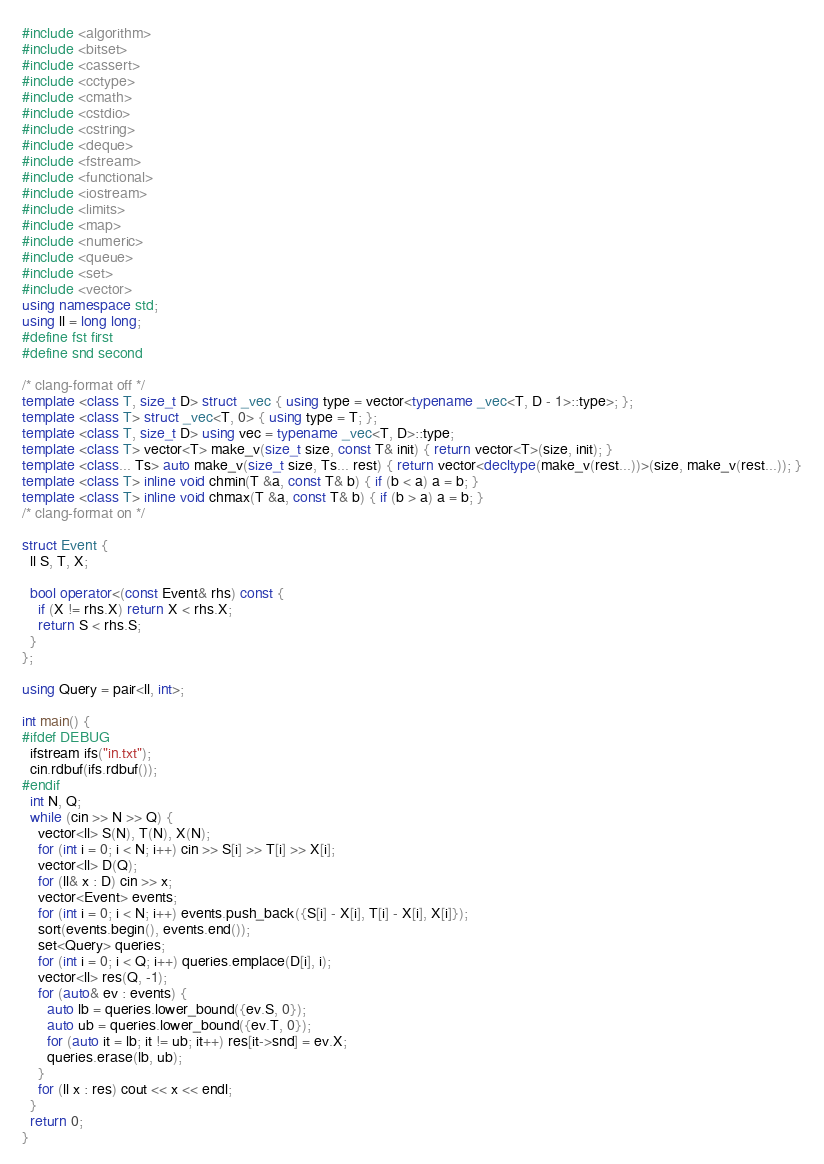<code> <loc_0><loc_0><loc_500><loc_500><_C++_>#include <algorithm>
#include <bitset>
#include <cassert>
#include <cctype>
#include <cmath>
#include <cstdio>
#include <cstring>
#include <deque>
#include <fstream>
#include <functional>
#include <iostream>
#include <limits>
#include <map>
#include <numeric>
#include <queue>
#include <set>
#include <vector>
using namespace std;
using ll = long long;
#define fst first
#define snd second

/* clang-format off */
template <class T, size_t D> struct _vec { using type = vector<typename _vec<T, D - 1>::type>; };
template <class T> struct _vec<T, 0> { using type = T; };
template <class T, size_t D> using vec = typename _vec<T, D>::type;
template <class T> vector<T> make_v(size_t size, const T& init) { return vector<T>(size, init); }
template <class... Ts> auto make_v(size_t size, Ts... rest) { return vector<decltype(make_v(rest...))>(size, make_v(rest...)); }
template <class T> inline void chmin(T &a, const T& b) { if (b < a) a = b; }
template <class T> inline void chmax(T &a, const T& b) { if (b > a) a = b; }
/* clang-format on */

struct Event {
  ll S, T, X;

  bool operator<(const Event& rhs) const {
    if (X != rhs.X) return X < rhs.X;
    return S < rhs.S;
  }
};

using Query = pair<ll, int>;

int main() {
#ifdef DEBUG
  ifstream ifs("in.txt");
  cin.rdbuf(ifs.rdbuf());
#endif
  int N, Q;
  while (cin >> N >> Q) {
    vector<ll> S(N), T(N), X(N);
    for (int i = 0; i < N; i++) cin >> S[i] >> T[i] >> X[i];
    vector<ll> D(Q);
    for (ll& x : D) cin >> x;
    vector<Event> events;
    for (int i = 0; i < N; i++) events.push_back({S[i] - X[i], T[i] - X[i], X[i]});
    sort(events.begin(), events.end());
    set<Query> queries;
    for (int i = 0; i < Q; i++) queries.emplace(D[i], i);
    vector<ll> res(Q, -1);
    for (auto& ev : events) {
      auto lb = queries.lower_bound({ev.S, 0});
      auto ub = queries.lower_bound({ev.T, 0});
      for (auto it = lb; it != ub; it++) res[it->snd] = ev.X;
      queries.erase(lb, ub);
    }
    for (ll x : res) cout << x << endl;
  }
  return 0;
}
</code> 